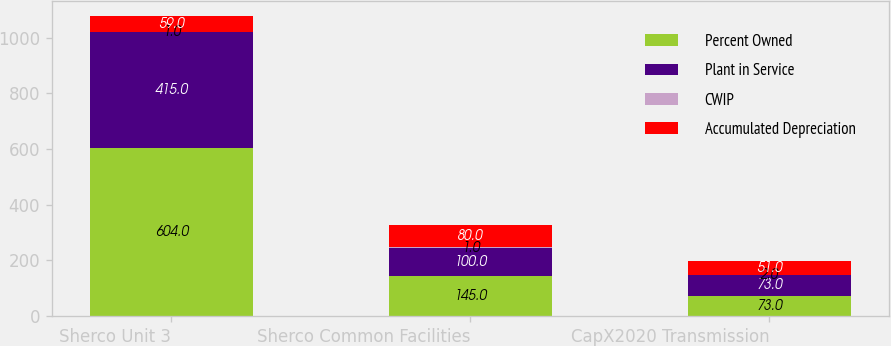<chart> <loc_0><loc_0><loc_500><loc_500><stacked_bar_chart><ecel><fcel>Sherco Unit 3<fcel>Sherco Common Facilities<fcel>CapX2020 Transmission<nl><fcel>Percent Owned<fcel>604<fcel>145<fcel>73<nl><fcel>Plant in Service<fcel>415<fcel>100<fcel>73<nl><fcel>CWIP<fcel>1<fcel>1<fcel>2<nl><fcel>Accumulated Depreciation<fcel>59<fcel>80<fcel>51<nl></chart> 